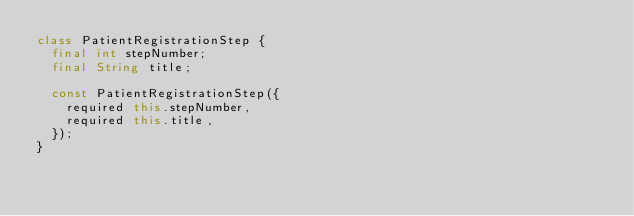Convert code to text. <code><loc_0><loc_0><loc_500><loc_500><_Dart_>class PatientRegistrationStep {
  final int stepNumber;
  final String title;

  const PatientRegistrationStep({
    required this.stepNumber,
    required this.title,
  });
}
</code> 